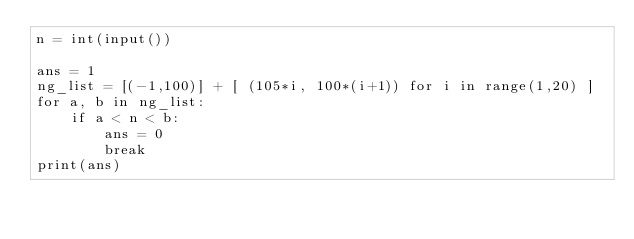<code> <loc_0><loc_0><loc_500><loc_500><_Python_>n = int(input())

ans = 1
ng_list = [(-1,100)] + [ (105*i, 100*(i+1)) for i in range(1,20) ]
for a, b in ng_list:
    if a < n < b:
        ans = 0
        break
print(ans)</code> 